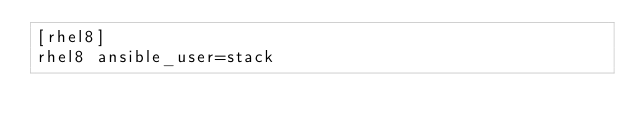Convert code to text. <code><loc_0><loc_0><loc_500><loc_500><_YAML_>[rhel8]
rhel8 ansible_user=stack
</code> 